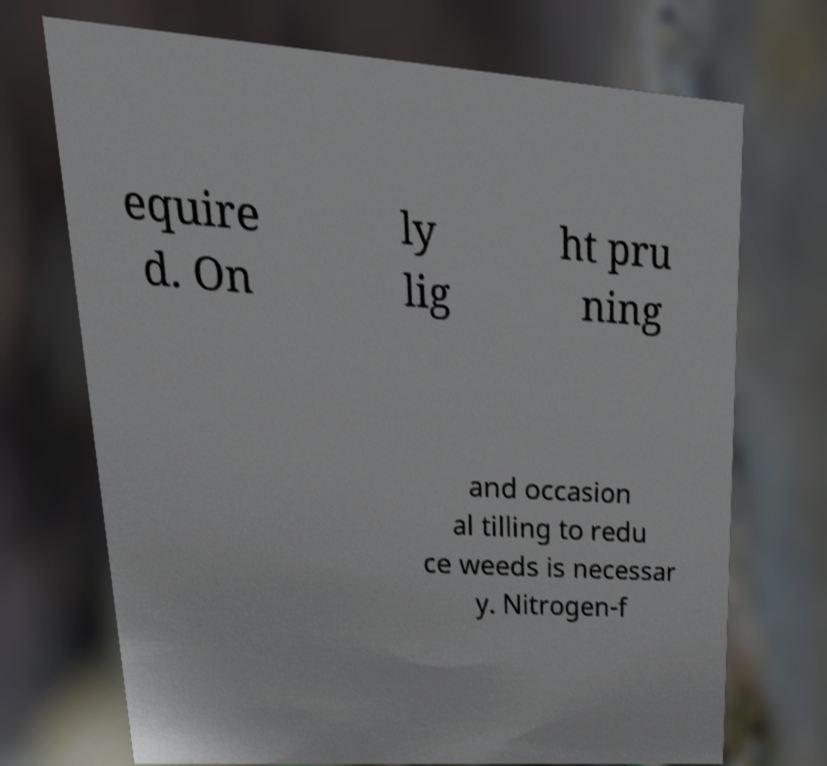Could you assist in decoding the text presented in this image and type it out clearly? equire d. On ly lig ht pru ning and occasion al tilling to redu ce weeds is necessar y. Nitrogen-f 